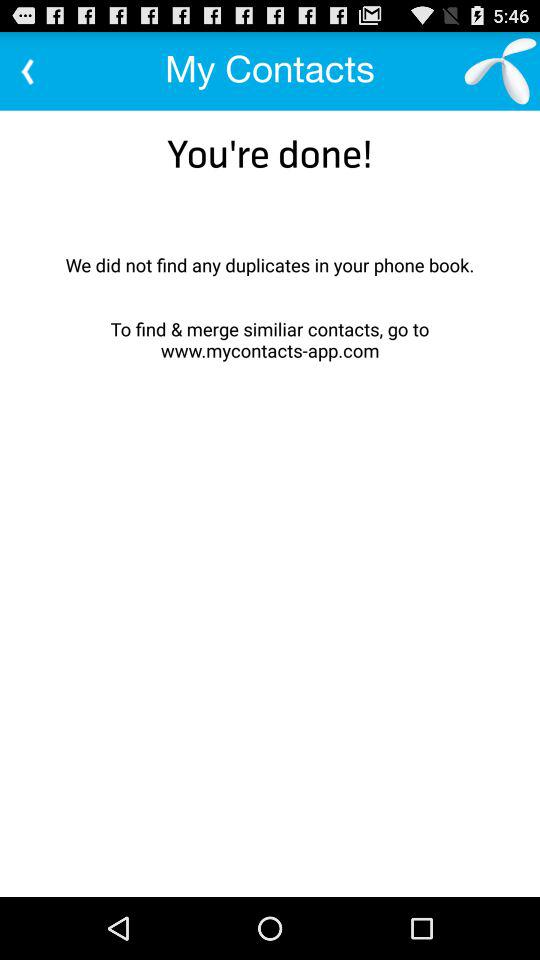What is the web site of "My Contacts"? The website is www.mycontacts-app.com. 